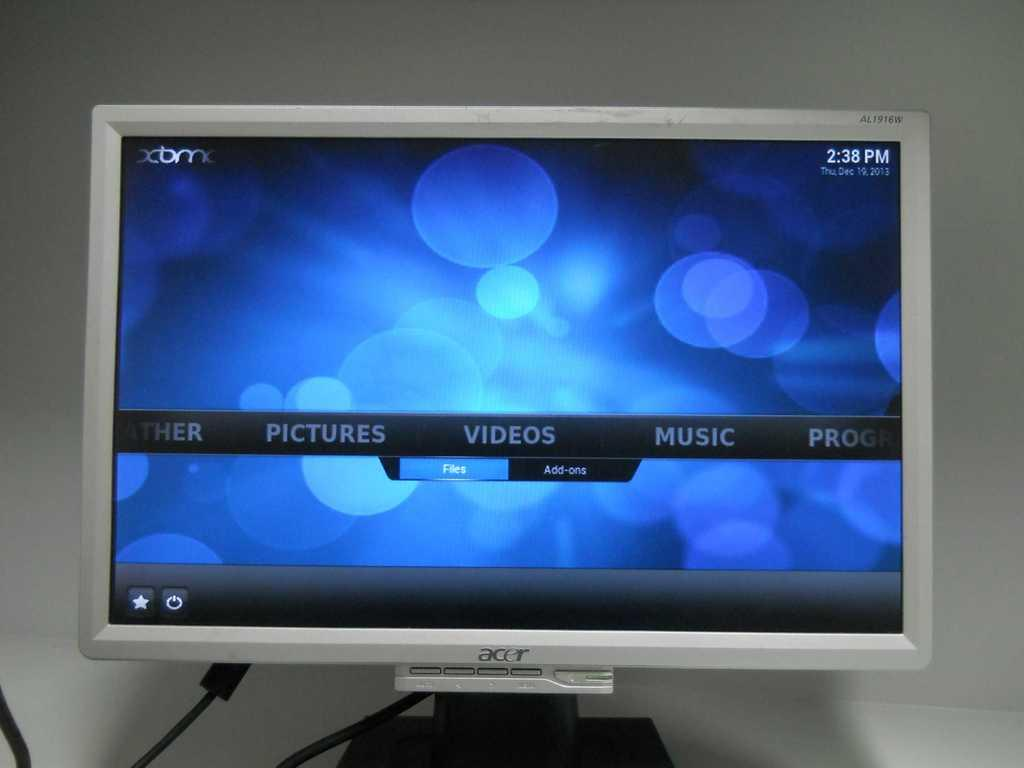Provide a one-sentence caption for the provided image. An Acer monitor with a scrolling media menu reading "Pictures", "Videos", "Music", and "Programs". 